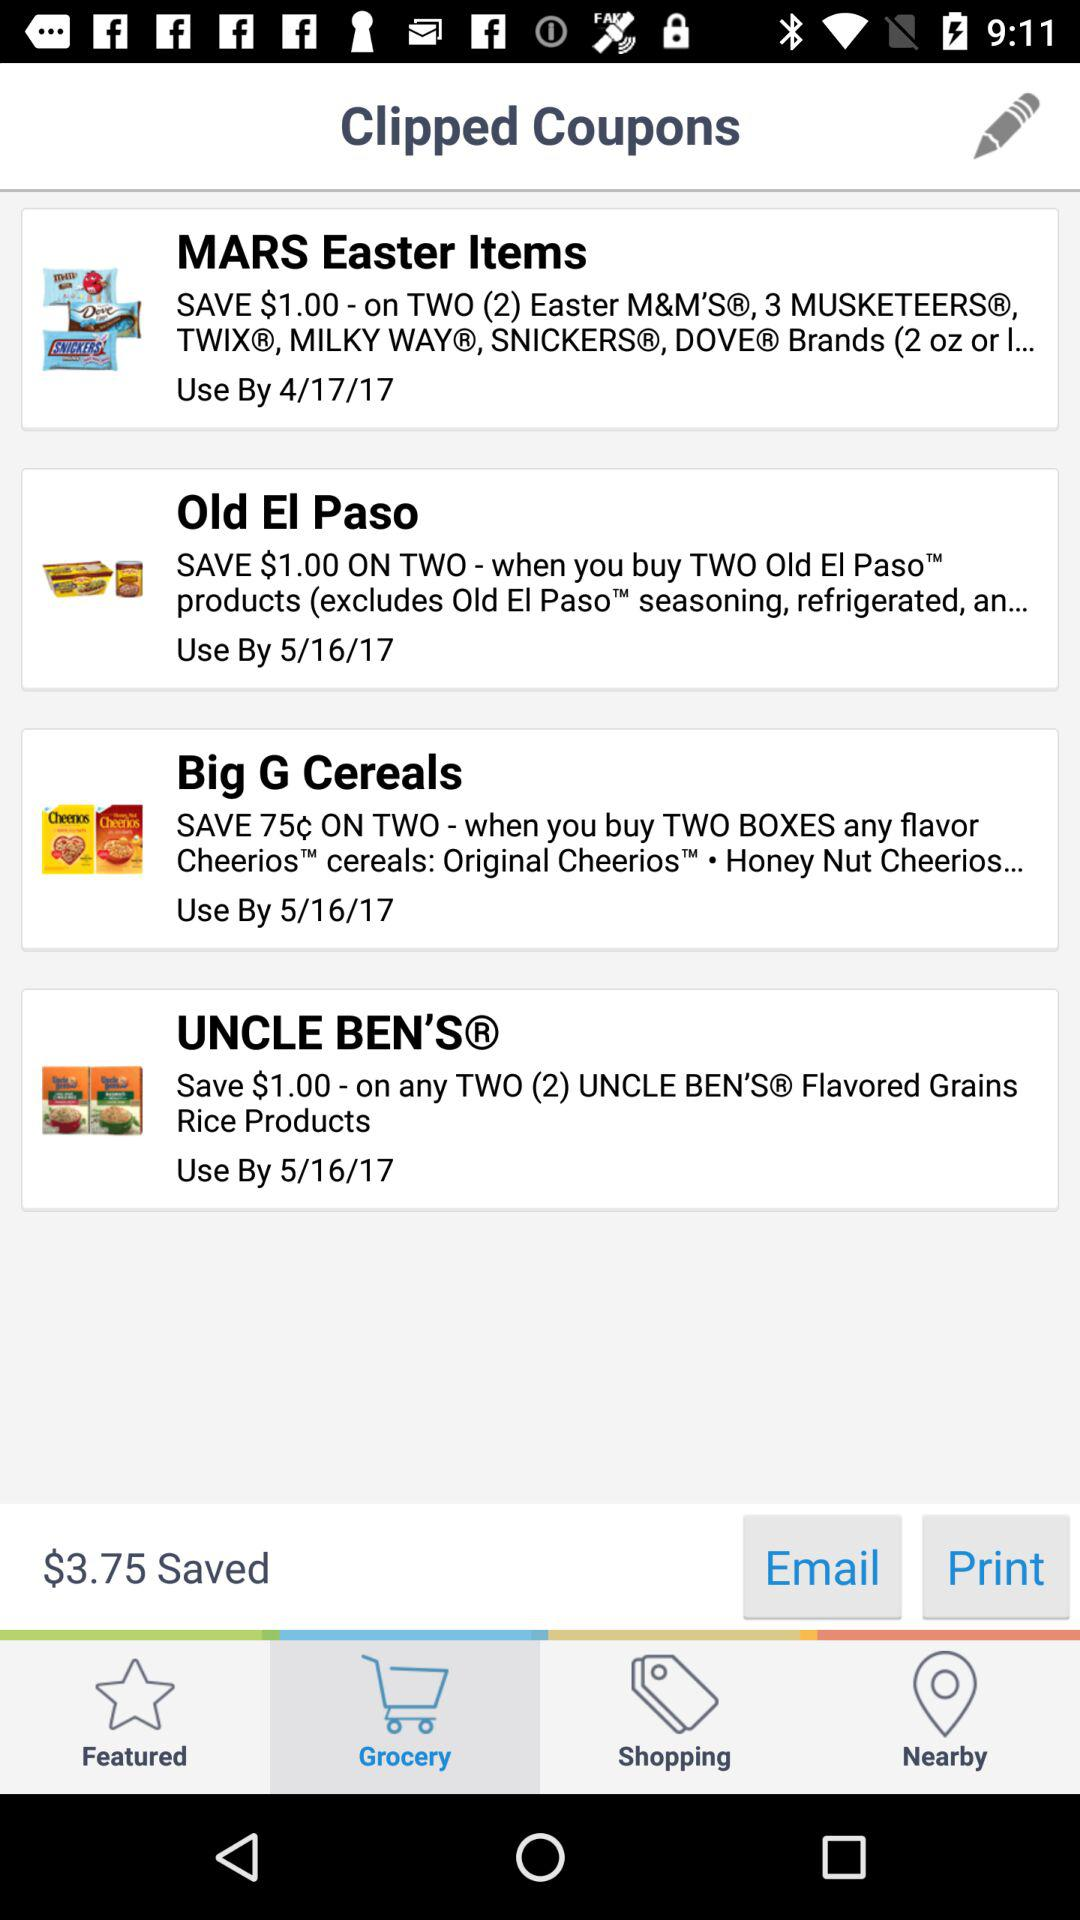Which tab is selected? The selected tab is "Grocery". 